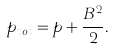Convert formula to latex. <formula><loc_0><loc_0><loc_500><loc_500>p _ { t o t } = p + \frac { B ^ { 2 } } { 2 } .</formula> 